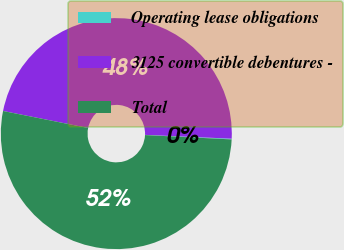Convert chart to OTSL. <chart><loc_0><loc_0><loc_500><loc_500><pie_chart><fcel>Operating lease obligations<fcel>3125 convertible debentures -<fcel>Total<nl><fcel>0.1%<fcel>47.56%<fcel>52.34%<nl></chart> 